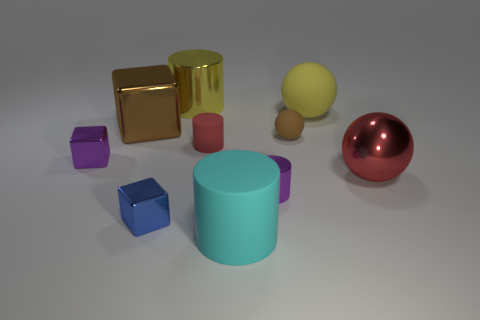Subtract all cylinders. How many objects are left? 6 Add 5 yellow shiny cylinders. How many yellow shiny cylinders are left? 6 Add 5 red rubber things. How many red rubber things exist? 6 Subtract 1 blue cubes. How many objects are left? 9 Subtract all big cyan rubber blocks. Subtract all yellow matte things. How many objects are left? 9 